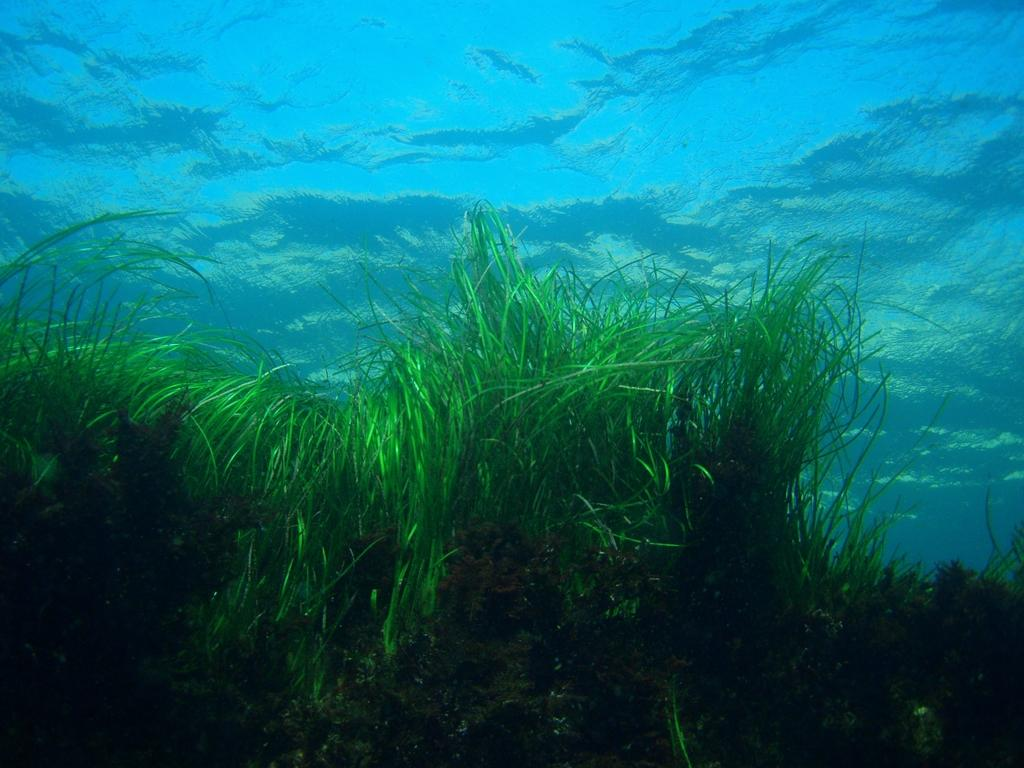What is the primary element visible in the image? There is water in the image. What type of vegetation can be seen at the bottom of the image? There is grass at the bottom of the image. What religion is practiced by the water in the image? There is no indication of religion in the image, as it features water and grass. How does the grass grip the water in the image? The grass does not grip the water in the image; it is a separate element. 